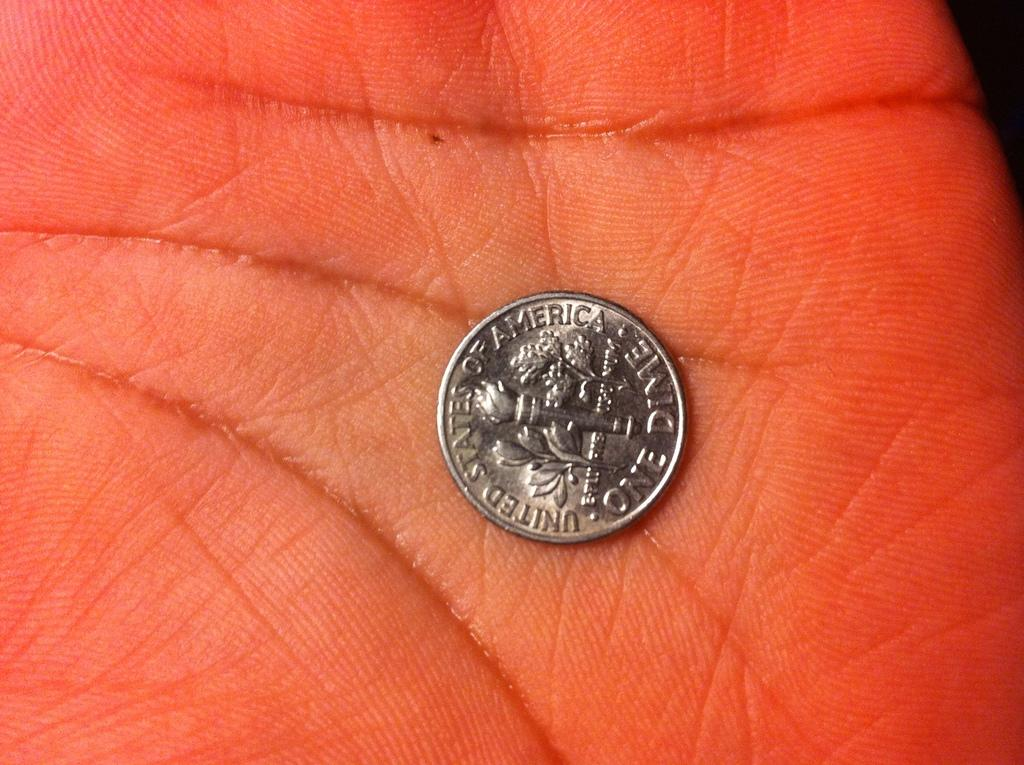Provide a one-sentence caption for the provided image. a coin that has the word america on it. 